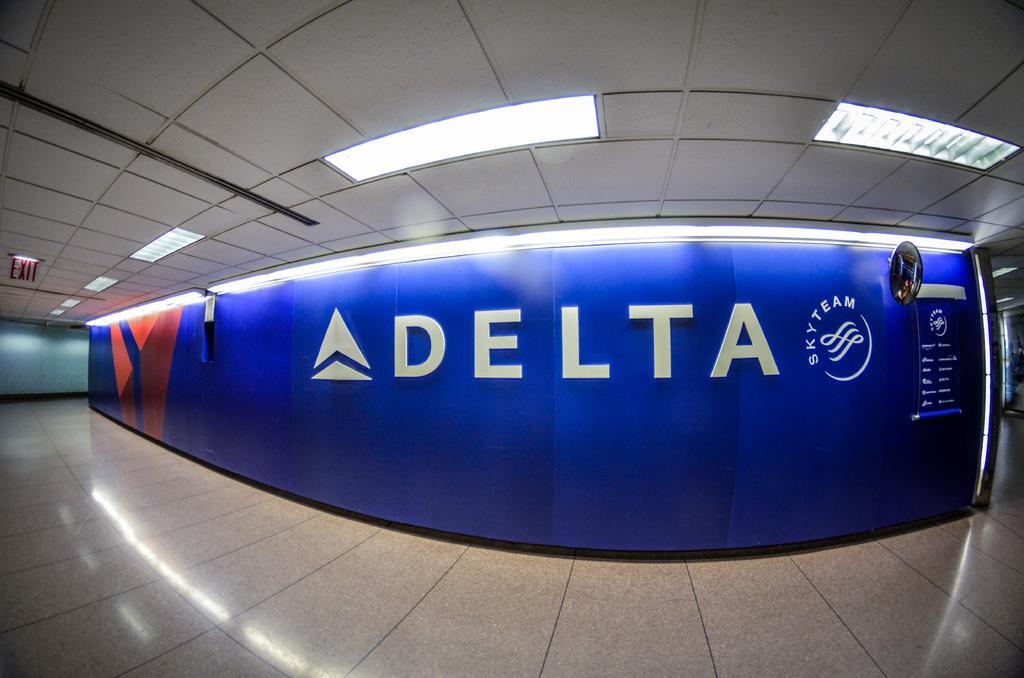In one or two sentences, can you explain what this image depicts? In this image at the bottom we can see floor. We can see texts written on the wall. At the top we can see lights on the ceiling. 